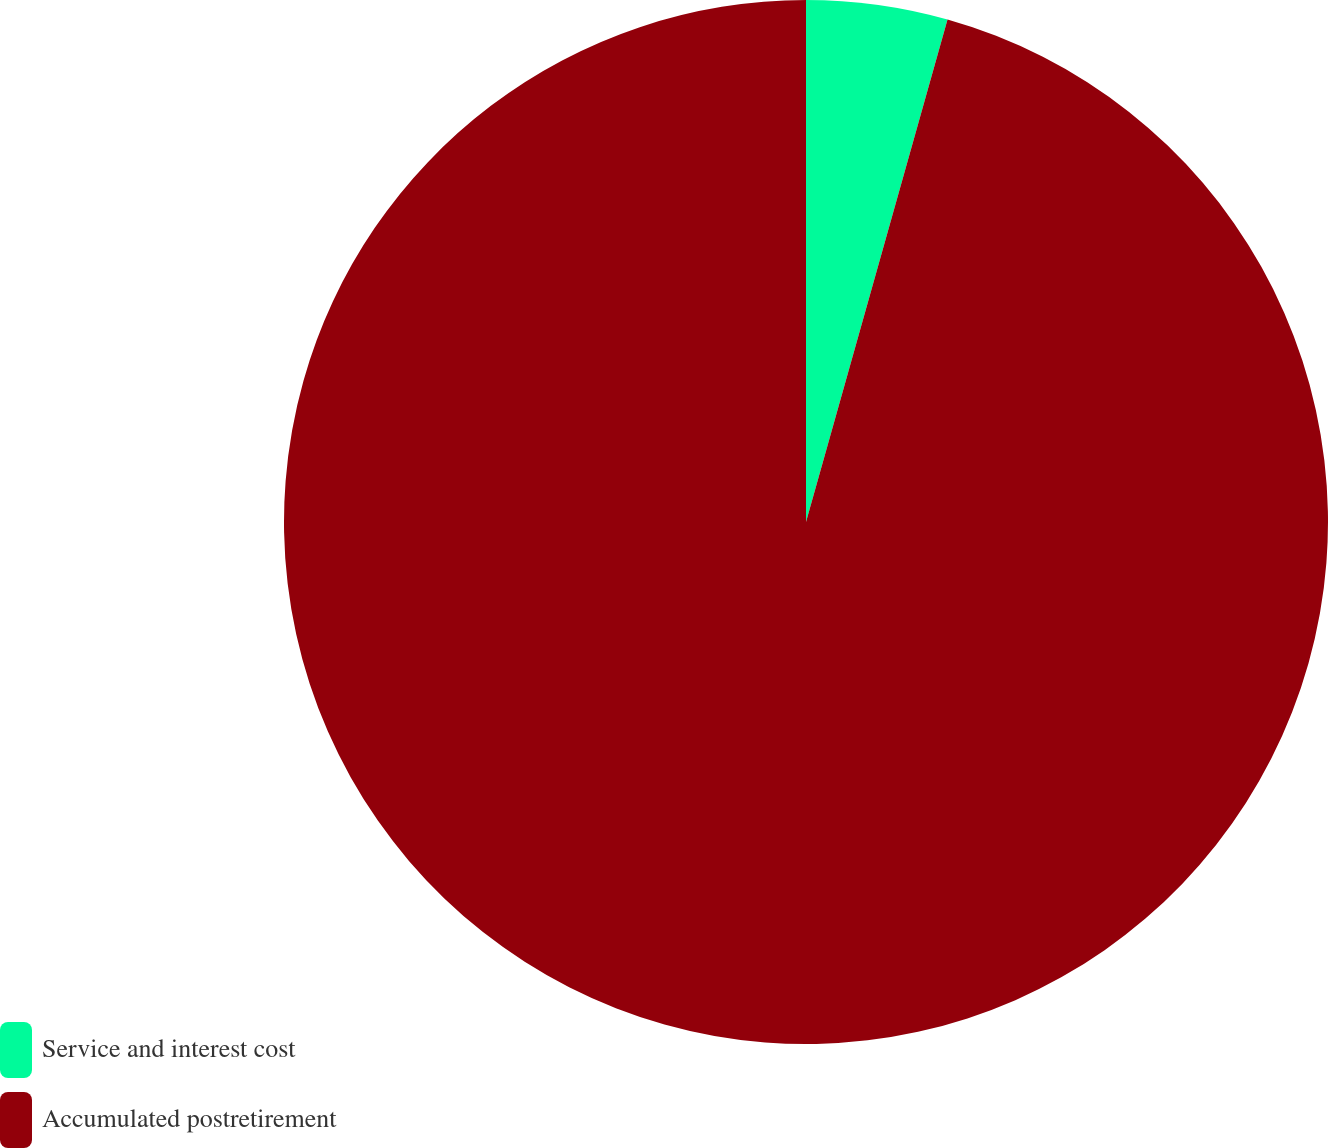Convert chart. <chart><loc_0><loc_0><loc_500><loc_500><pie_chart><fcel>Service and interest cost<fcel>Accumulated postretirement<nl><fcel>4.37%<fcel>95.63%<nl></chart> 